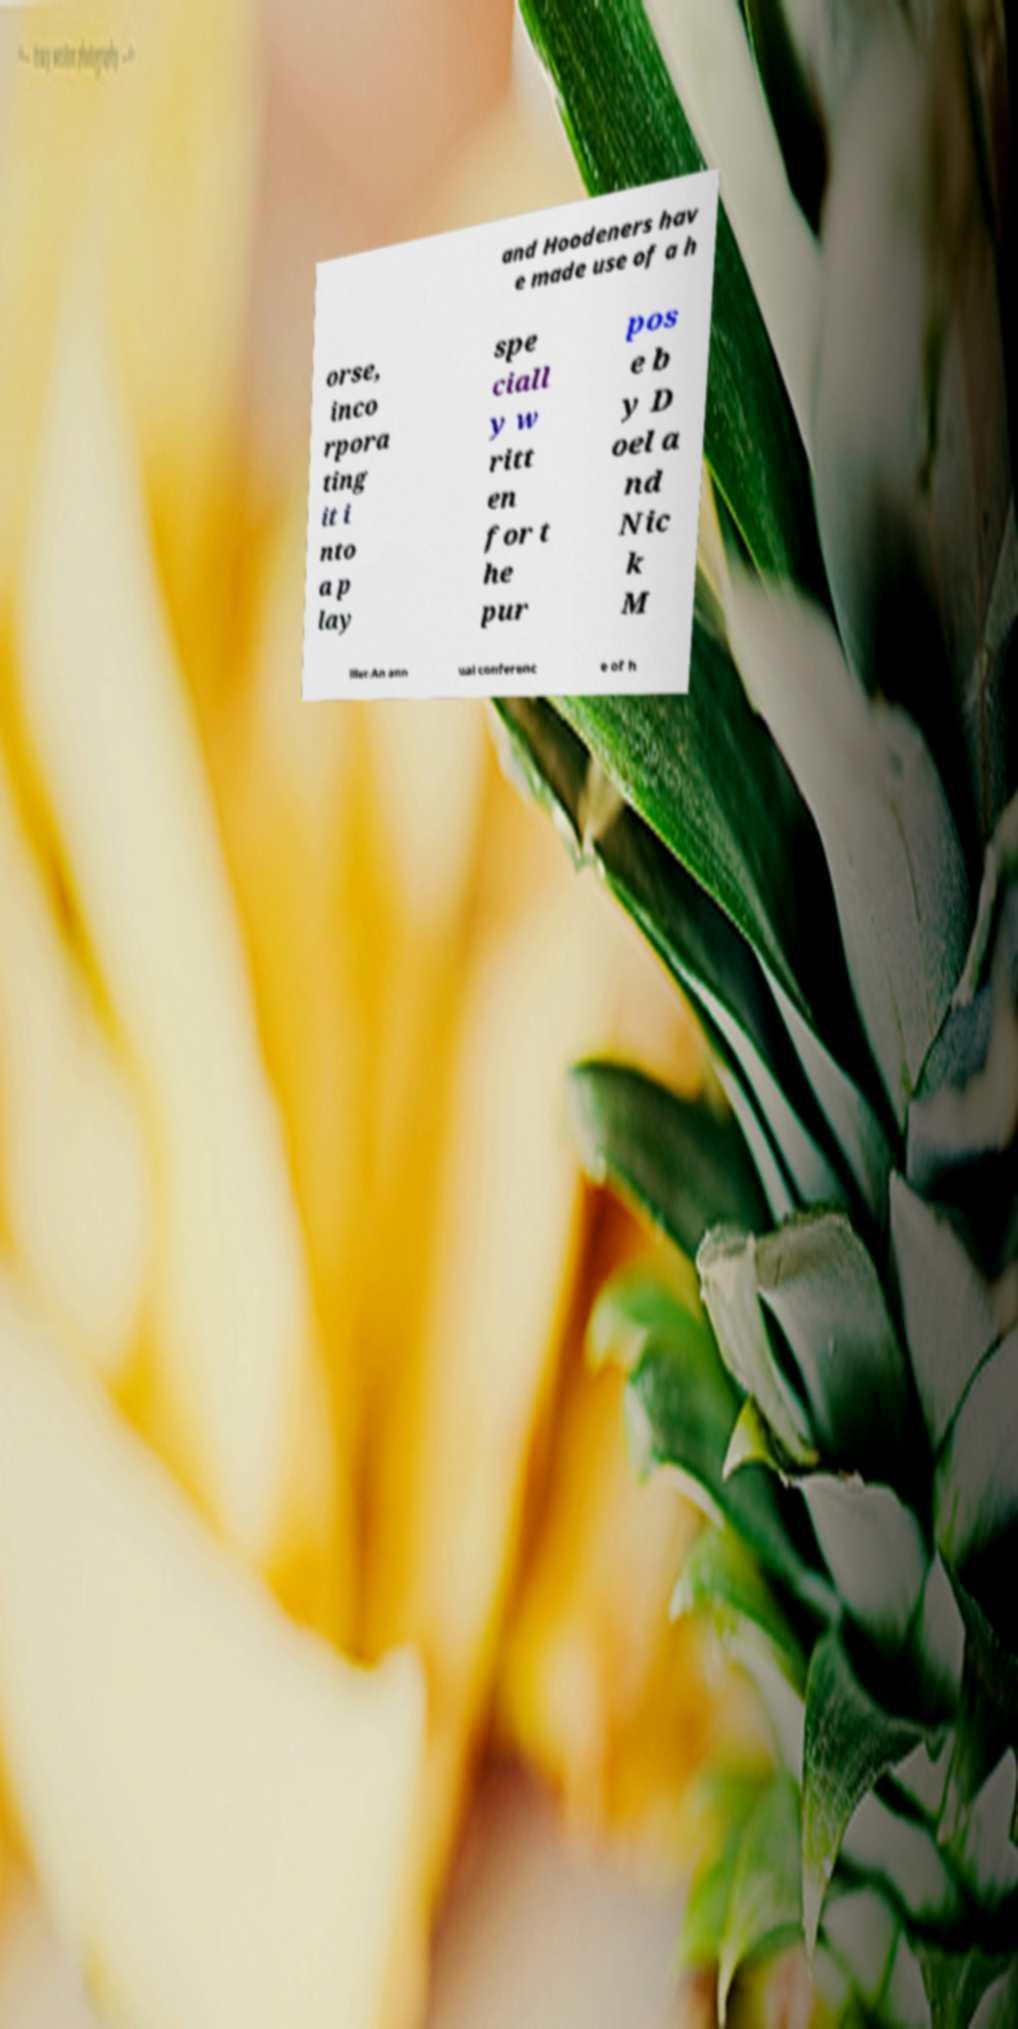I need the written content from this picture converted into text. Can you do that? and Hoodeners hav e made use of a h orse, inco rpora ting it i nto a p lay spe ciall y w ritt en for t he pur pos e b y D oel a nd Nic k M iller.An ann ual conferenc e of h 